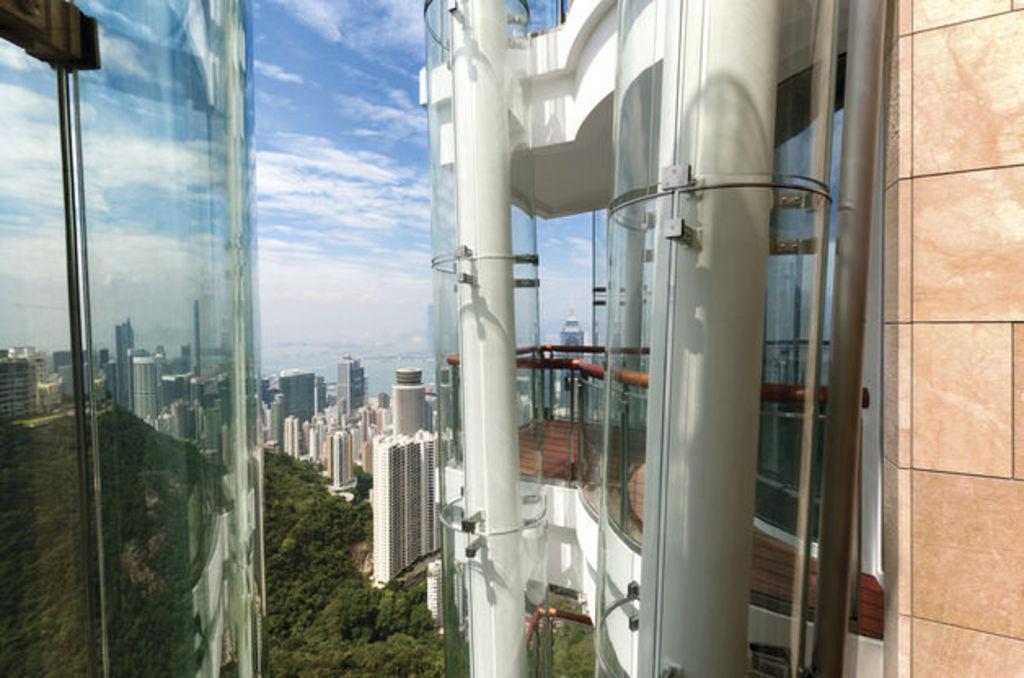Please provide a concise description of this image. In the picture I can see buildings, trees and the sky. Here I can see framed glass walls and some other objects. 